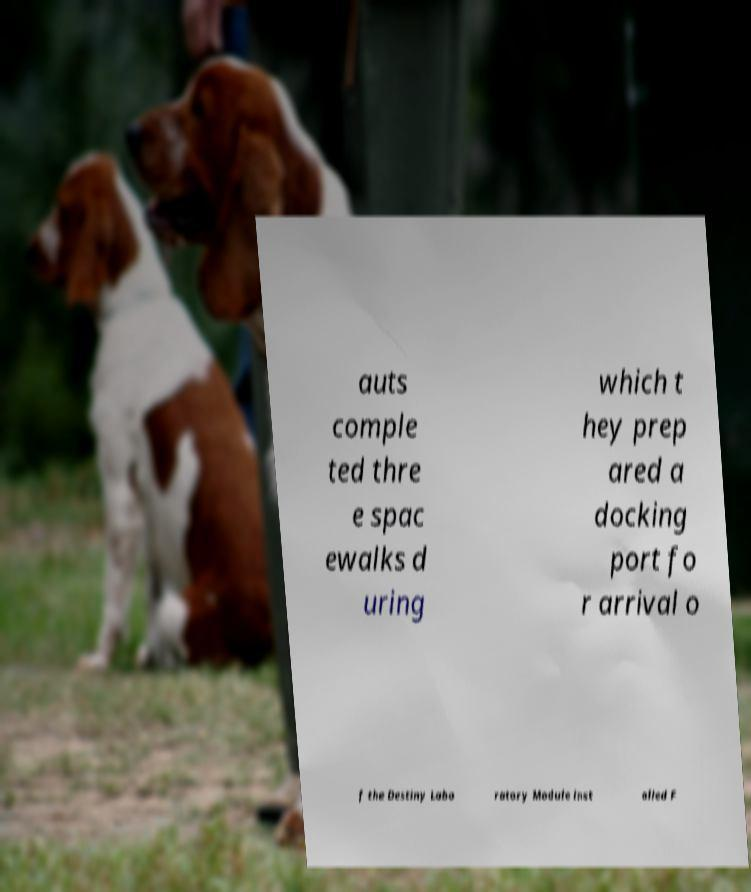What messages or text are displayed in this image? I need them in a readable, typed format. auts comple ted thre e spac ewalks d uring which t hey prep ared a docking port fo r arrival o f the Destiny Labo ratory Module inst alled F 